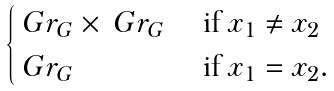<formula> <loc_0><loc_0><loc_500><loc_500>\begin{cases} \ G r _ { G } \times \ G r _ { G } & \text { if } x _ { 1 } \ne x _ { 2 } \\ \ G r _ { G } & \text { if } x _ { 1 } = x _ { 2 } . \end{cases}</formula> 